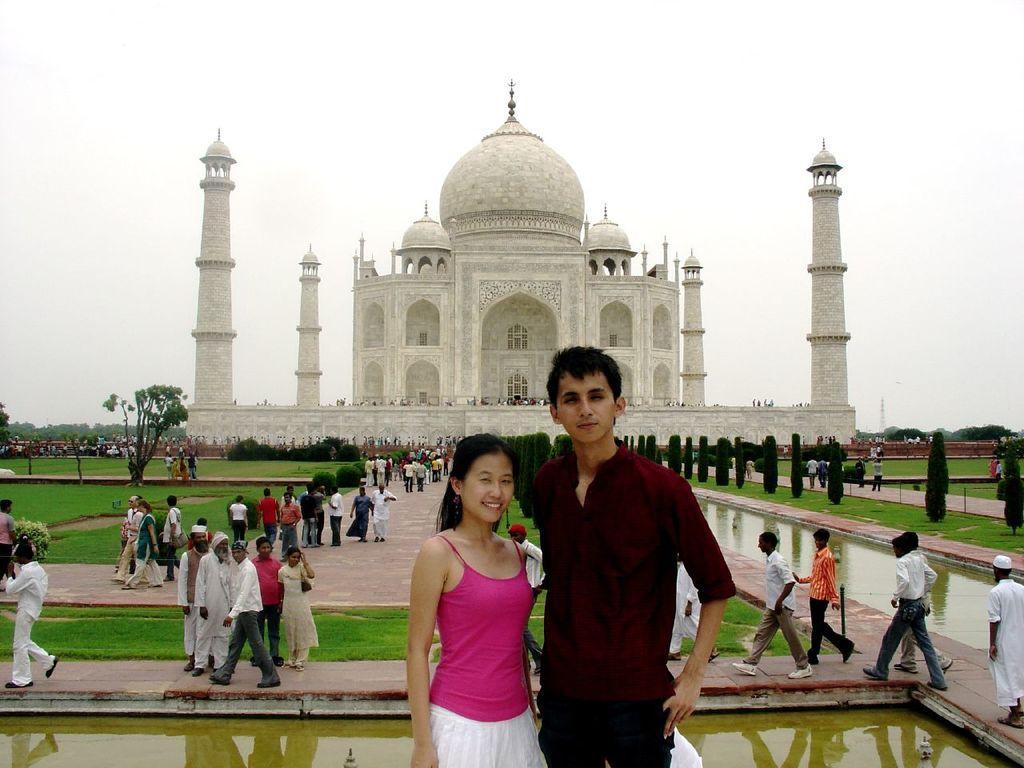Can you describe this image briefly? In this image I can see a crowd on the road, ponds, grass, trees and a fence. In the background I can see pillars, a historical monument and the sky. This image is taken may be during a day. 